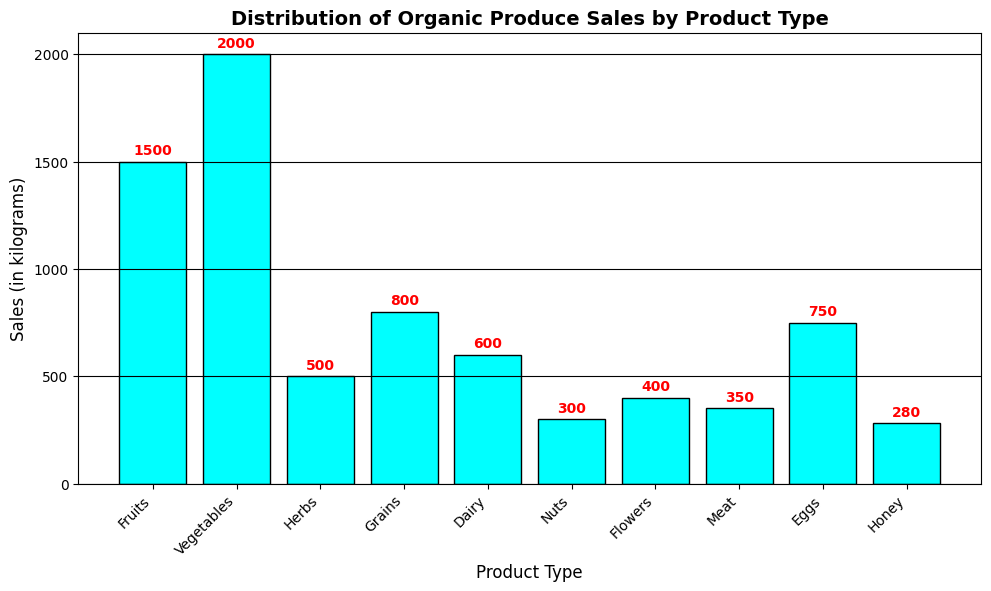Which product type has the highest sales? By looking at the bar chart, the tallest bar represents Vegetables with sales of 2000 kilograms.
Answer: Vegetables Which product type has the lowest sales? The shortest bar represents Nuts with sales of 300 kilograms.
Answer: Nuts What is the total sales of Herbs and Dairy combined? The sales for Herbs are 500 kilograms and for Dairy are 600 kilograms. Adding these gives 500 + 600 = 1100 kilograms.
Answer: 1100 How do the sales of Fruits compare to Vegetables? Fruits have sales of 1500 kilograms and Vegetables have sales of 2000 kilograms. Vegetables have higher sales than Fruits.
Answer: Vegetables have higher sales Which has more sales, Grains or Meat? The bar for Grains shows 800 kilograms, and for Meat, it shows 350 kilograms. Grains have more sales than Meat.
Answer: Grains What is the average sales amount for the given product types? Sum all sales: 1500 + 2000 + 500 + 800 + 600 + 300 + 400 + 350 + 750 + 280 = 7480 kilograms. Divide by the number of product types, which is 10: 7480 / 10 = 748 kilograms.
Answer: 748 How much more are the sales of Vegetables than Nuts? Sales for Vegetables are 2000 kilograms and for Nuts are 300 kilograms. The difference is 2000 - 300 = 1700 kilograms.
Answer: 1700 Are sales of Eggs greater than sales of Fruits and Herbs combined? Sales of Eggs are 750 kilograms. Combined sales of Fruits (1500 kilograms) and Herbs (500 kilograms) are 1500 + 500 = 2000 kilograms. Eggs have lower sales than the combined sales of Fruits and Herbs.
Answer: No What product types have sales between 400 and 800 kilograms? The bars representing sales in this range are Grains (800 kilograms), Flowers (400 kilograms), Eggs (750 kilograms), and Dairy (600 kilograms).
Answer: Grains, Eggs, and Dairy What is the visual difference in bar color for the product types? Each bar is colored in cyan with a black edge, making them uniform in color.
Answer: All bars are cyan with black edges 